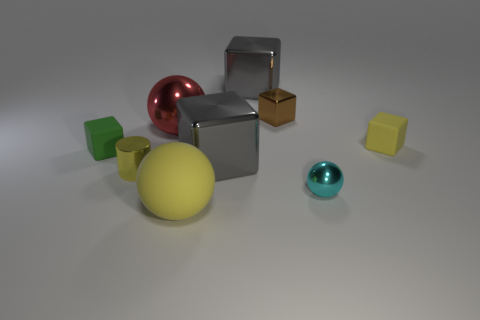What number of green objects are either small metal objects or big metal blocks?
Your response must be concise. 0. How many metal cylinders have the same color as the rubber ball?
Offer a very short reply. 1. Is the tiny yellow block made of the same material as the tiny green cube?
Ensure brevity in your answer.  Yes. There is a gray block that is behind the big metal sphere; what number of rubber things are to the left of it?
Offer a terse response. 2. Do the green matte thing and the yellow shiny cylinder have the same size?
Your answer should be very brief. Yes. What number of tiny cylinders have the same material as the brown cube?
Your answer should be very brief. 1. What is the size of the other shiny object that is the same shape as the red thing?
Provide a short and direct response. Small. Is the shape of the gray metal thing that is behind the brown metal object the same as  the small cyan thing?
Your answer should be very brief. No. There is a big shiny thing that is in front of the rubber cube right of the yellow rubber ball; what is its shape?
Offer a very short reply. Cube. Is there any other thing that has the same shape as the yellow metallic object?
Your response must be concise. No. 